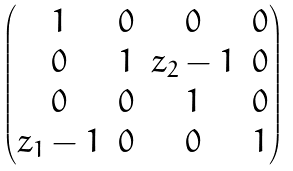<formula> <loc_0><loc_0><loc_500><loc_500>\begin{pmatrix} 1 & 0 & 0 & 0 \\ 0 & 1 & z _ { 2 } - 1 & 0 \\ 0 & 0 & 1 & 0 \\ z _ { 1 } - 1 & 0 & 0 & 1 \end{pmatrix}</formula> 